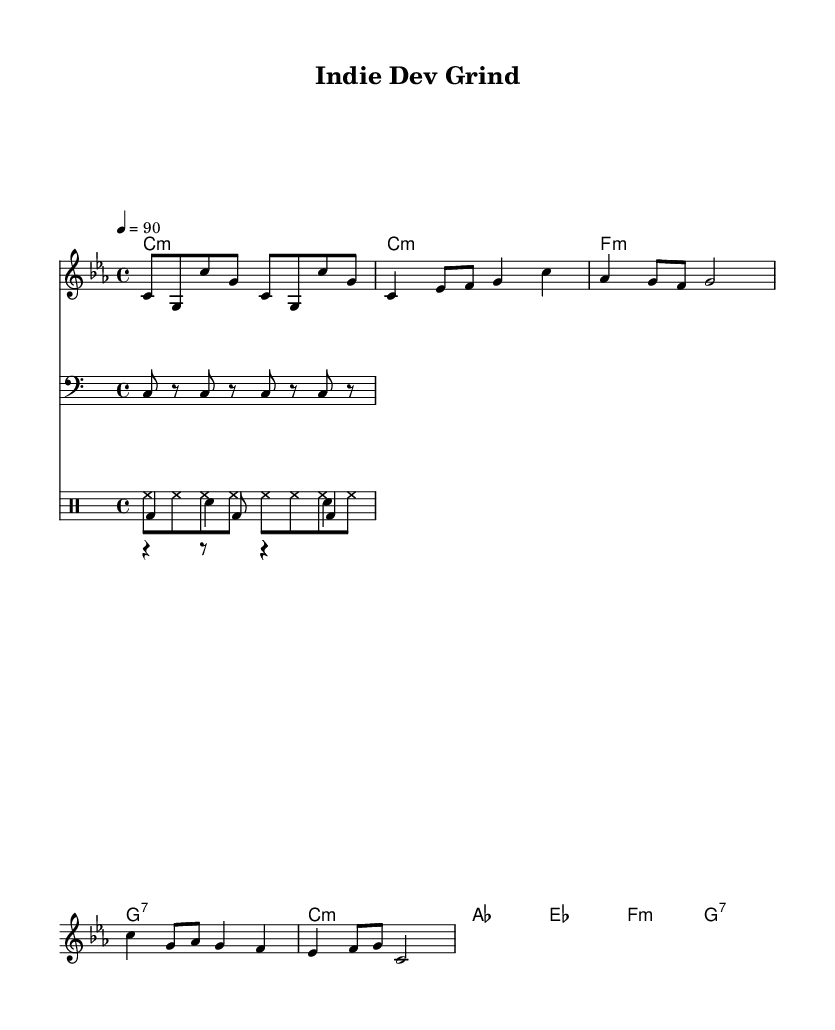What is the key signature of this music? The music is in C minor, indicated by the flat key signature featuring three flats (B♭, E♭, and A♭).
Answer: C minor What is the time signature of this music? The time signature is 4/4, which is indicated at the beginning of the score and means there are four beats in each measure.
Answer: 4/4 What is the tempo marking for this piece? The tempo marking indicates a speed of 90 beats per minute, which is noted in the score as "4 = 90".
Answer: 90 What is the primary mood conveyed in the chorus section? The chorus is set in a more uplifting and hopeful mood, as indicated by the chord progression shifting from A♭ major to E♭ major, giving a sense of triumph amidst struggles.
Answer: Uplifting How does the drum pattern contribute to the feel of the piece? The kick and snare drum patterns provide a steady foundation that complements the bass line and enhances the hip-hop feel, while the hi-hat pattern adds rhythm and drive to the music, typical of the genre.
Answer: Provides rhythm What type of chord progression is used in the verse? The verse uses a minor chord progression, specifically consisting of minor chords and a dominant seventh chord, reflecting the challenges faced in indie game development.
Answer: Minor How many measures are in the intro section? The intro section contains 4 measures, as indicated by the notation provided for that part of the music.
Answer: 4 